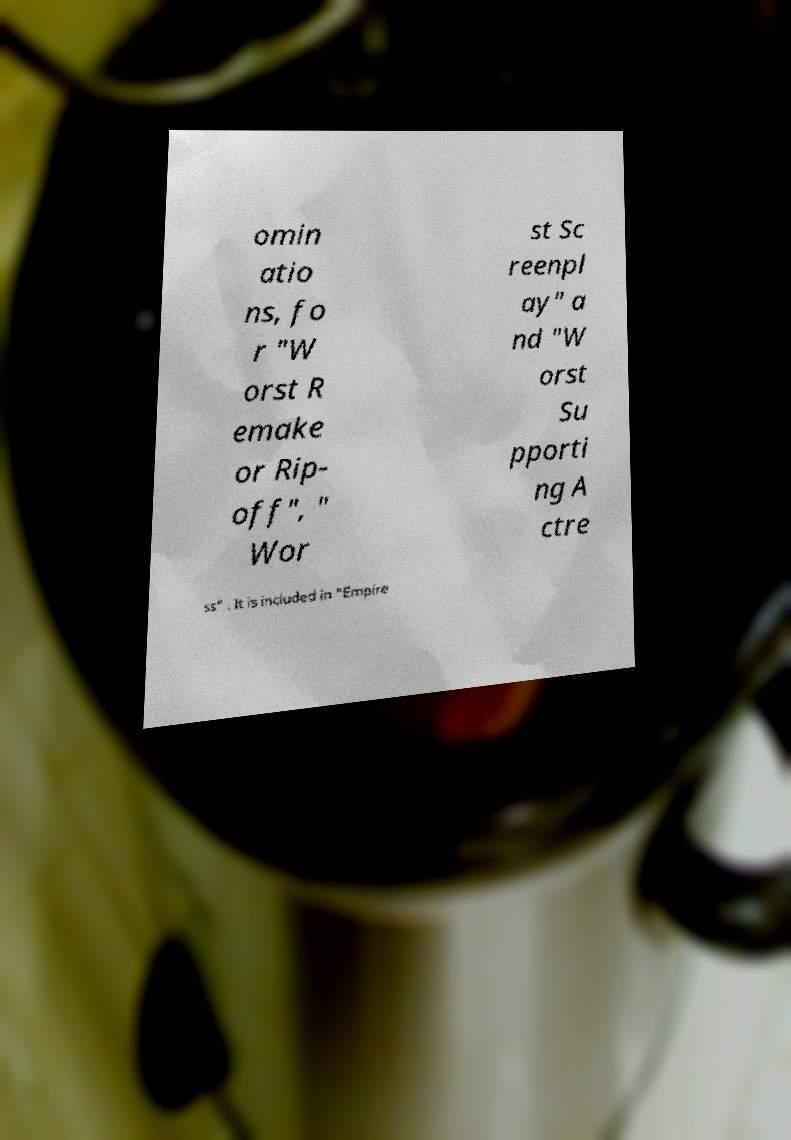There's text embedded in this image that I need extracted. Can you transcribe it verbatim? omin atio ns, fo r "W orst R emake or Rip- off", " Wor st Sc reenpl ay" a nd "W orst Su pporti ng A ctre ss" . It is included in "Empire 